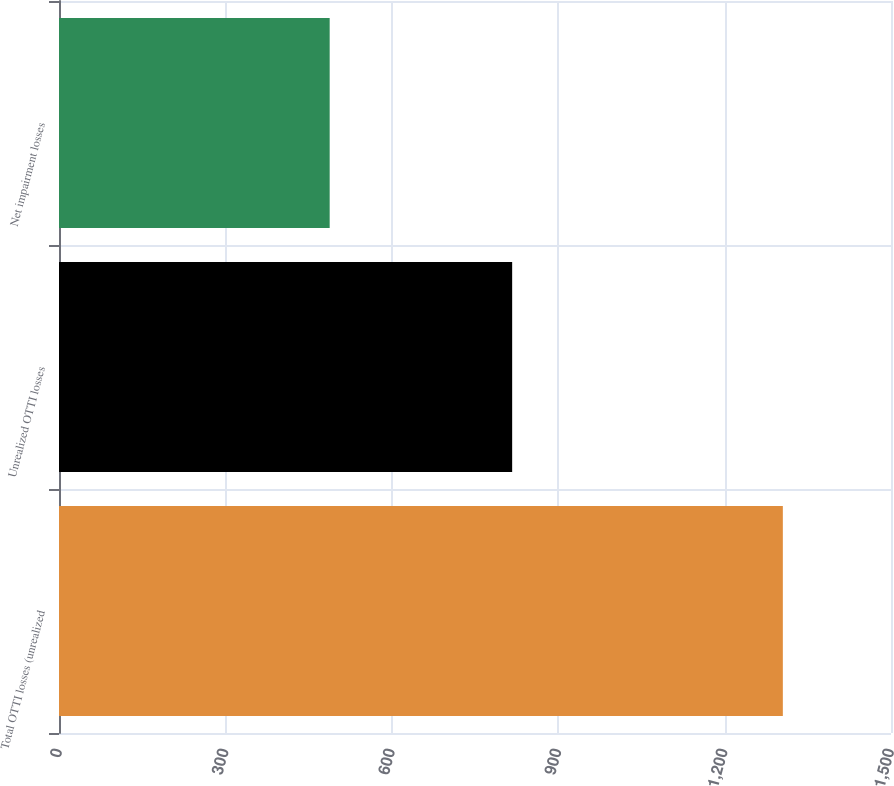Convert chart to OTSL. <chart><loc_0><loc_0><loc_500><loc_500><bar_chart><fcel>Total OTTI losses (unrealized<fcel>Unrealized OTTI losses<fcel>Net impairment losses<nl><fcel>1305<fcel>817<fcel>488<nl></chart> 